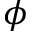Convert formula to latex. <formula><loc_0><loc_0><loc_500><loc_500>\phi</formula> 